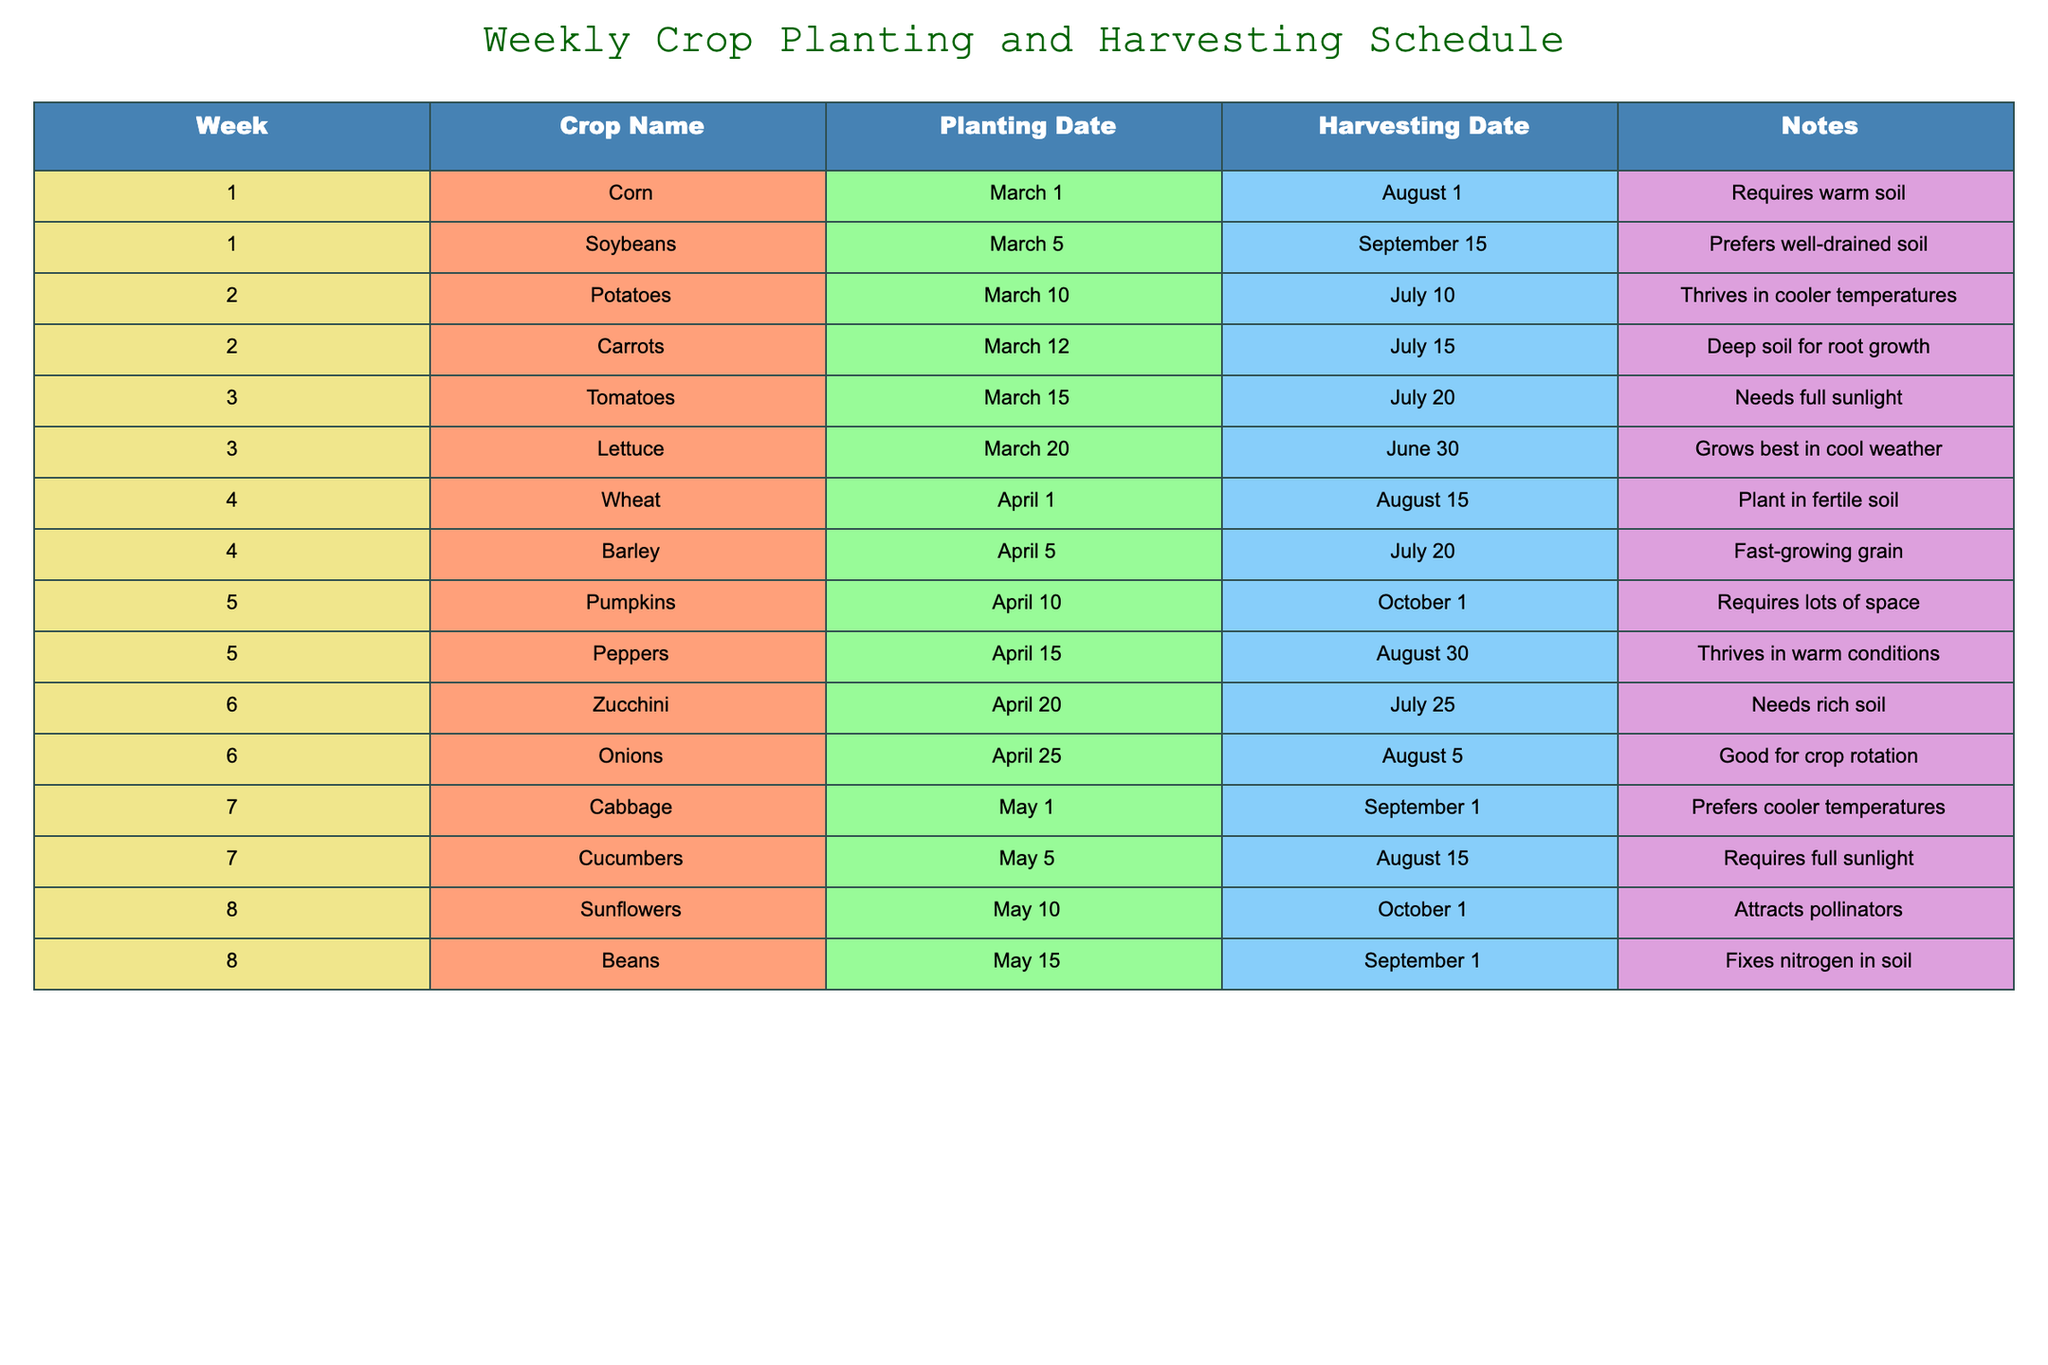What is the harvesting date for corn? Looking at the table, I locate the row corresponding to corn, which is found in week 1. The harvesting date listed for corn is August 1.
Answer: August 1 Which crop is planted in week 2 and requires cooler temperatures? Referring to week 2, I see potatoes planted on March 10, and their harvesting date is July 10. The notes indicate that potatoes thrive in cooler temperatures.
Answer: Potatoes How many crops are harvested in July? Going through the table, I count the crops that have their harvesting dates in July: potatoes (July 10), lettuce (June 30), zucchini (July 25), and onions (August 5). That gives a total of 3 crops harvested in July.
Answer: 3 Do sunflowers attract pollinators? Checking the notes for sunflowers listed in week 8, the note specifically mentions that they attract pollinators, confirming that this fact is true.
Answer: Yes What is the average planting date of crops for week 5 and their respective harvesting dates? In week 5, the crops listed are pumpkins (planted on April 10, harvested October 1) and peppers (planted on April 15, harvested August 30). For the planting dates, the average is calculated as (10 + 15) / 2 = 12.5, and for harvesting dates, (10/1 + 8/30) = 9/15.
Answer: Average planting date is April 12.5, harvesting is September 15 